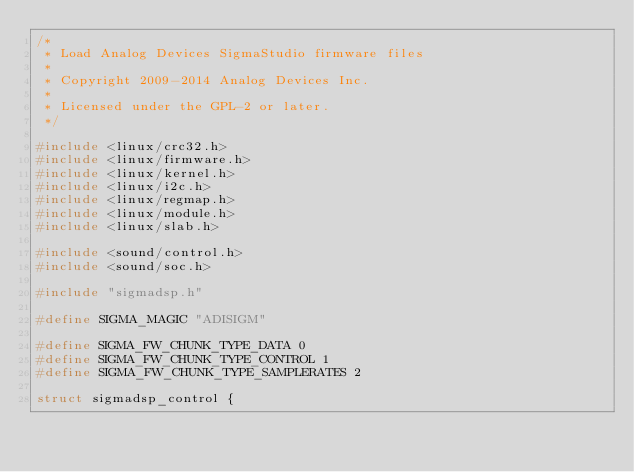Convert code to text. <code><loc_0><loc_0><loc_500><loc_500><_C_>/*
 * Load Analog Devices SigmaStudio firmware files
 *
 * Copyright 2009-2014 Analog Devices Inc.
 *
 * Licensed under the GPL-2 or later.
 */

#include <linux/crc32.h>
#include <linux/firmware.h>
#include <linux/kernel.h>
#include <linux/i2c.h>
#include <linux/regmap.h>
#include <linux/module.h>
#include <linux/slab.h>

#include <sound/control.h>
#include <sound/soc.h>

#include "sigmadsp.h"

#define SIGMA_MAGIC "ADISIGM"

#define SIGMA_FW_CHUNK_TYPE_DATA 0
#define SIGMA_FW_CHUNK_TYPE_CONTROL 1
#define SIGMA_FW_CHUNK_TYPE_SAMPLERATES 2

struct sigmadsp_control {</code> 